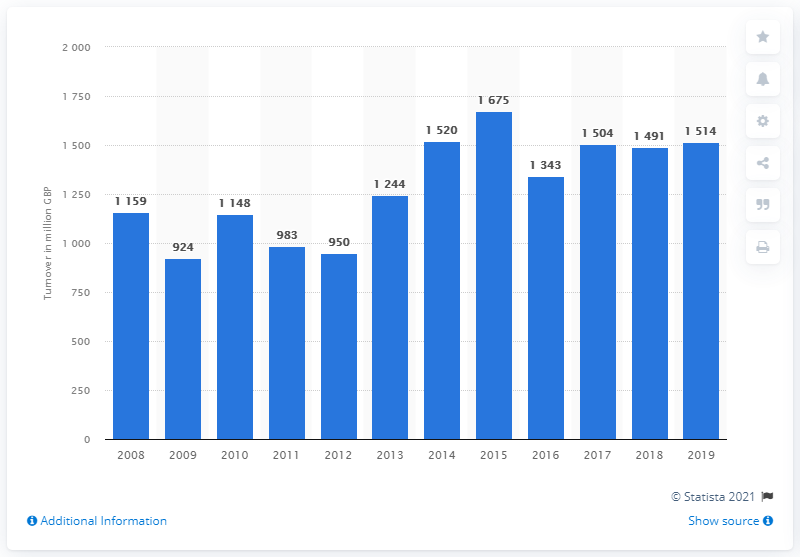Mention a couple of crucial points in this snapshot. The turnover of spare parts and accessories for all vehicle types in 2009 was 924. 